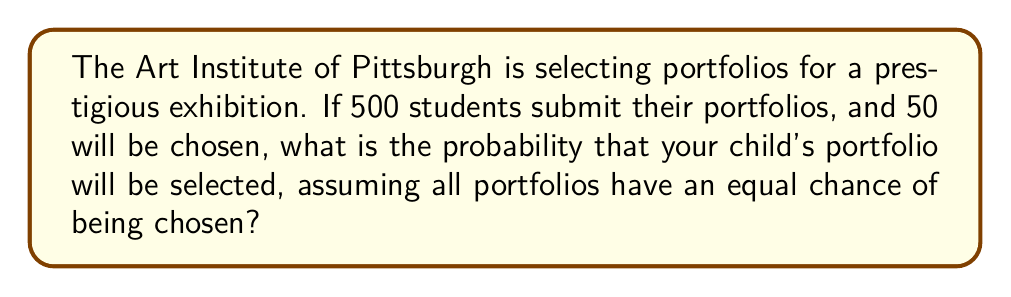Show me your answer to this math problem. Let's approach this step-by-step:

1) First, we need to identify the probability model. This is a simple random selection without replacement, where each portfolio has an equal chance of being chosen.

2) The probability of an event is calculated by:

   $$ P(\text{event}) = \frac{\text{number of favorable outcomes}}{\text{total number of possible outcomes}} $$

3) In this case:
   - Total number of portfolios (possible outcomes) = 500
   - Number of portfolios selected (favorable outcomes) = 50

4) Plugging these numbers into our probability formula:

   $$ P(\text{selection}) = \frac{50}{500} $$

5) Simplify the fraction:

   $$ P(\text{selection}) = \frac{1}{10} = 0.1 $$

6) Convert to a percentage:

   $$ 0.1 \times 100\% = 10\% $$

Therefore, your child's portfolio has a 10% chance of being selected for the exhibition.
Answer: $\frac{1}{10}$ or 10% 